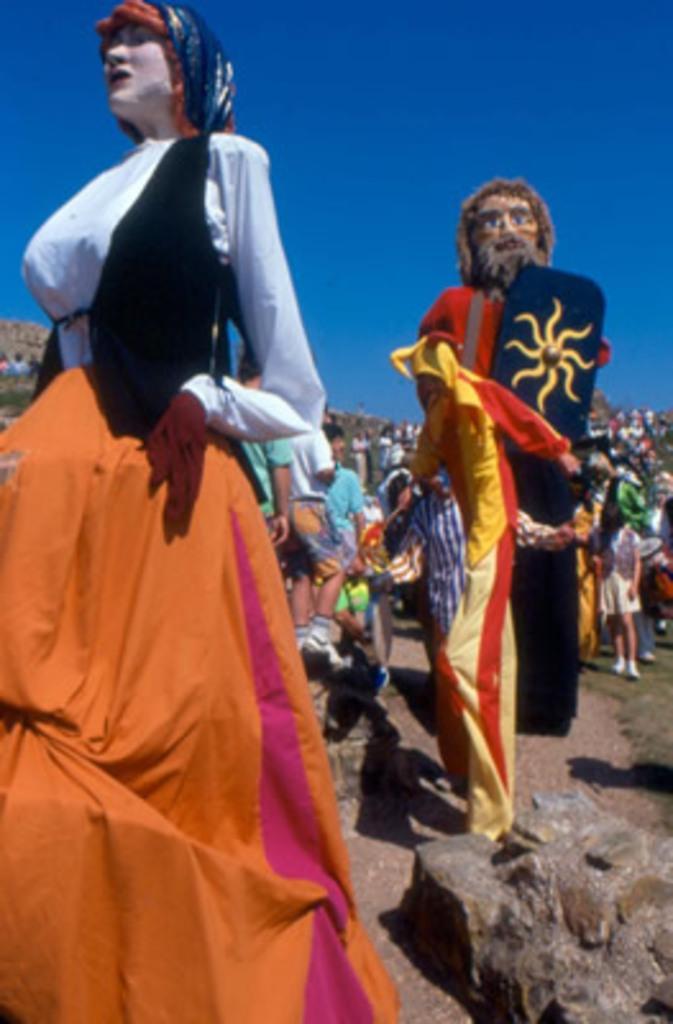Describe this image in one or two sentences. In the image in the center we can see two persons in different costumes. In the background we can see sky,building,trees,stones and group of people were standing. 